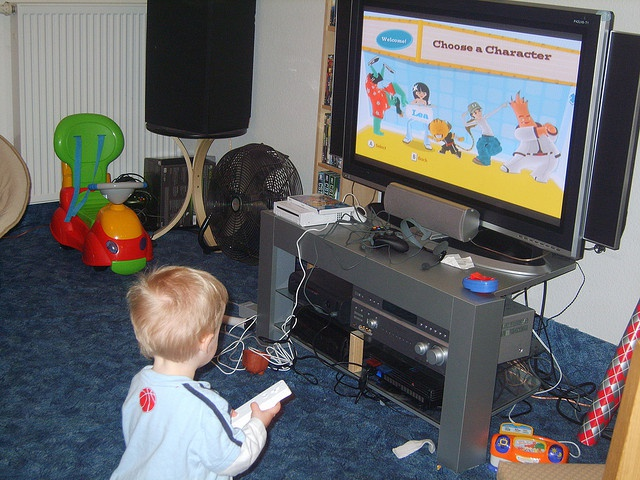Describe the objects in this image and their specific colors. I can see tv in darkgray, black, lightblue, lavender, and gold tones, people in darkgray, lightblue, tan, and gray tones, chair in darkgray and gray tones, remote in darkgray, white, lightpink, and black tones, and remote in darkgray, black, gray, and purple tones in this image. 